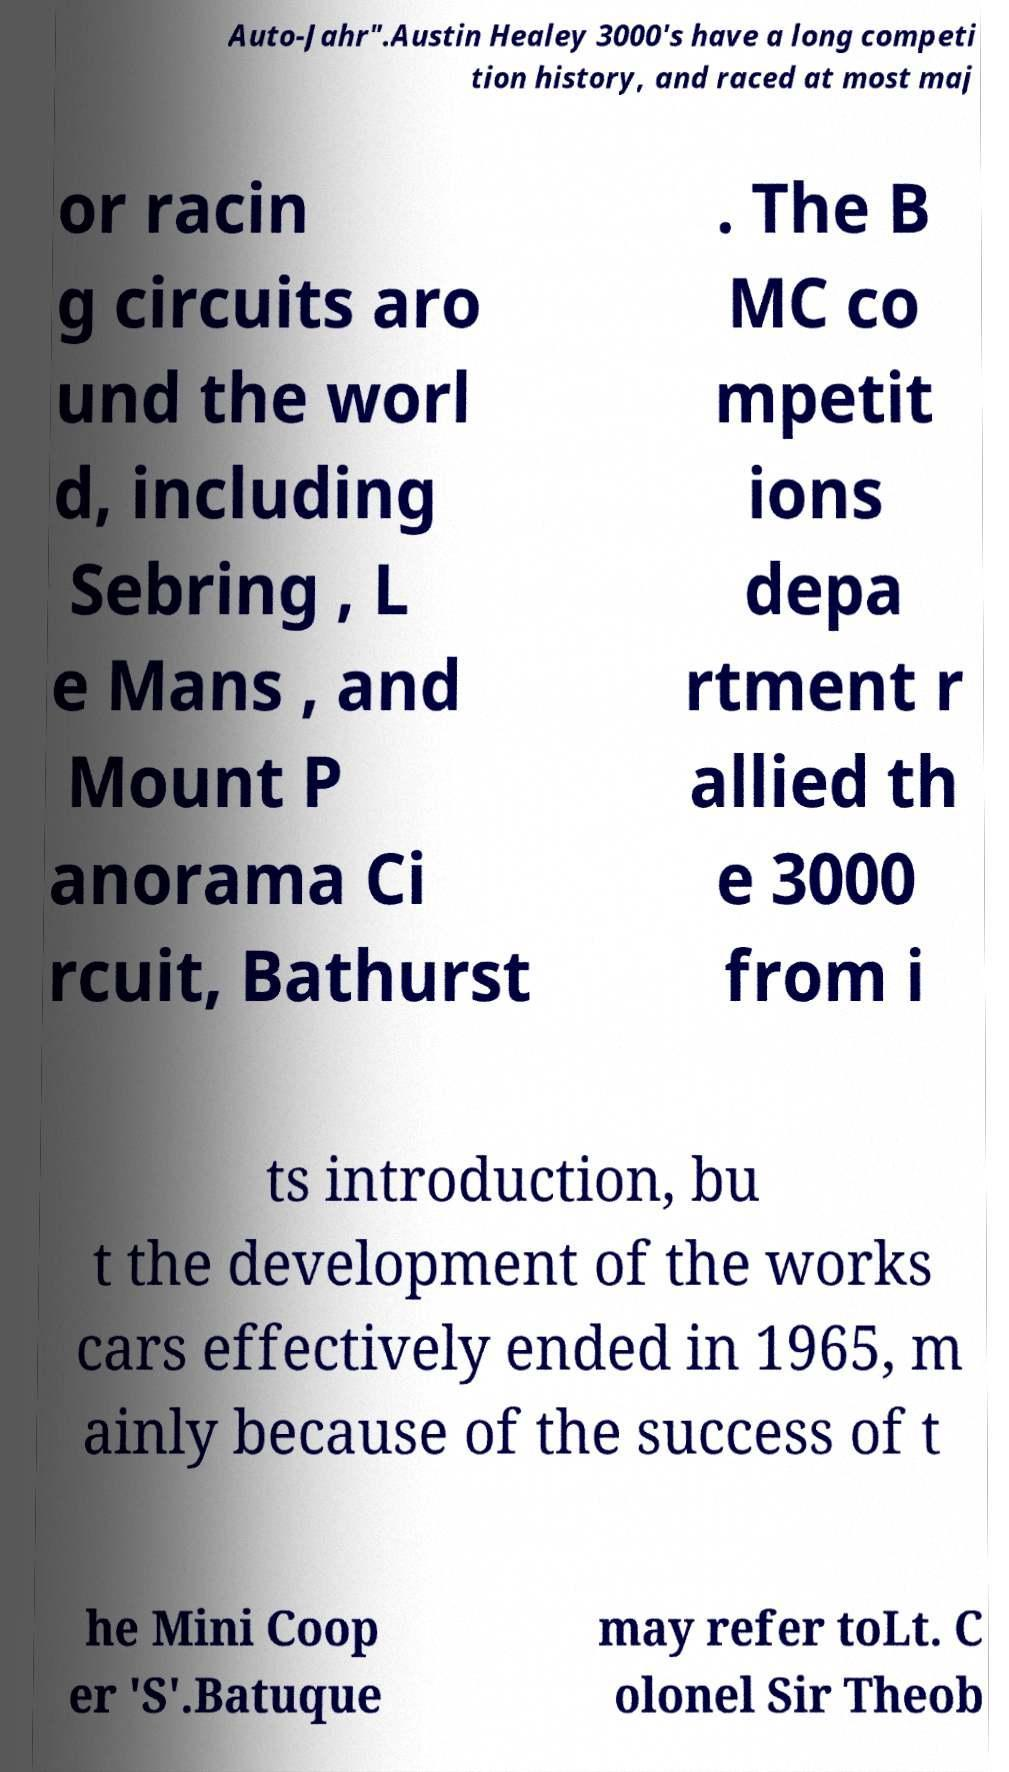For documentation purposes, I need the text within this image transcribed. Could you provide that? Auto-Jahr".Austin Healey 3000's have a long competi tion history, and raced at most maj or racin g circuits aro und the worl d, including Sebring , L e Mans , and Mount P anorama Ci rcuit, Bathurst . The B MC co mpetit ions depa rtment r allied th e 3000 from i ts introduction, bu t the development of the works cars effectively ended in 1965, m ainly because of the success of t he Mini Coop er 'S'.Batuque may refer toLt. C olonel Sir Theob 